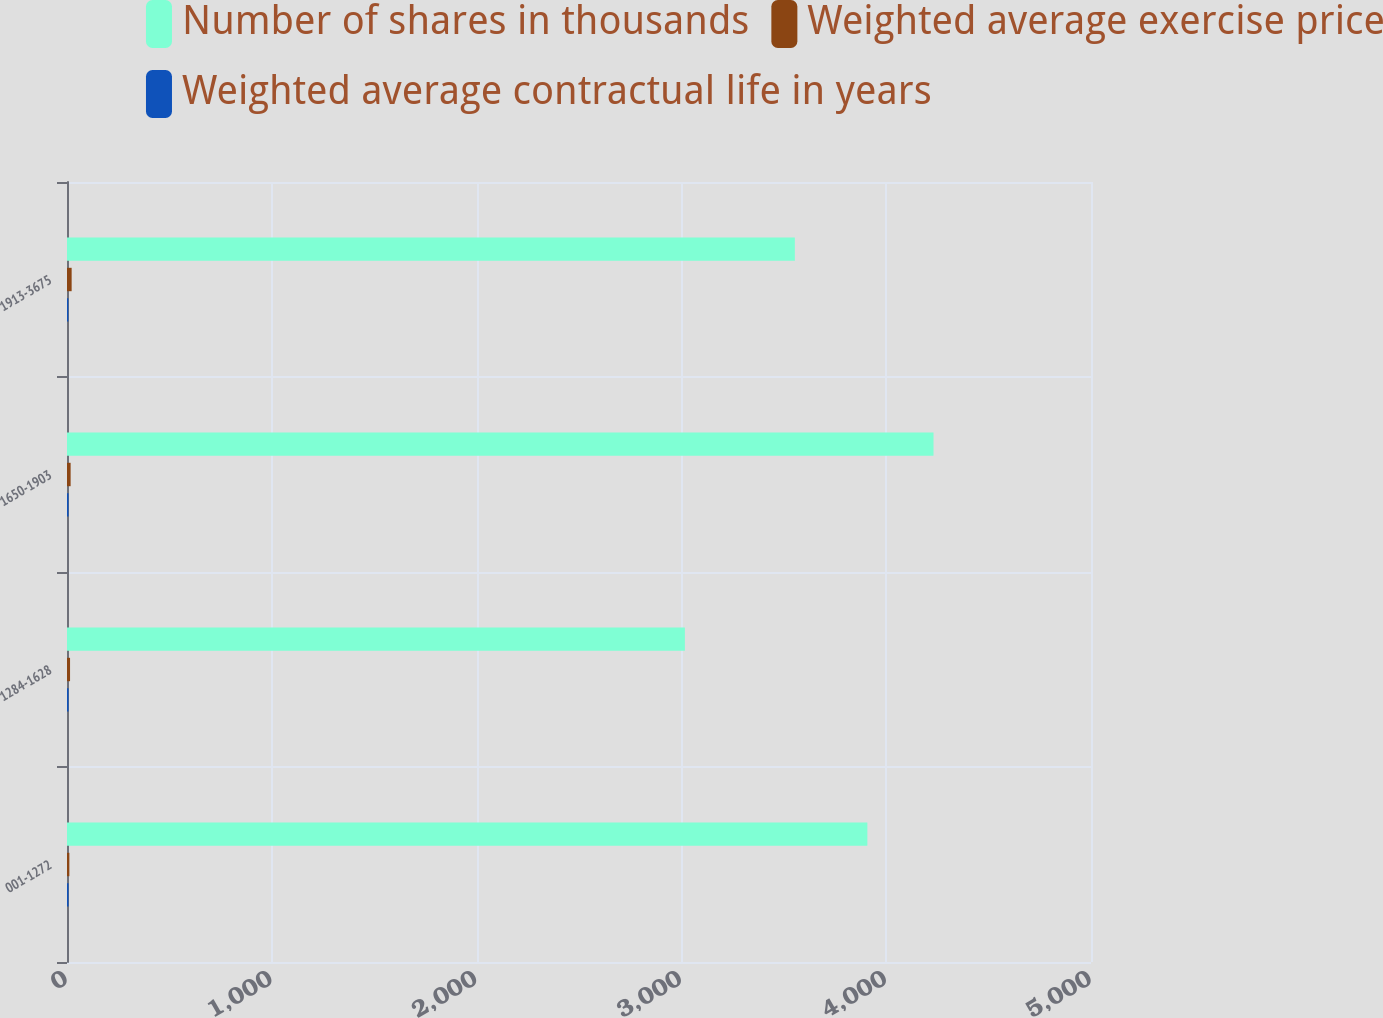<chart> <loc_0><loc_0><loc_500><loc_500><stacked_bar_chart><ecel><fcel>001-1272<fcel>1284-1628<fcel>1650-1903<fcel>1913-3675<nl><fcel>Number of shares in thousands<fcel>3908<fcel>3017<fcel>4231<fcel>3554<nl><fcel>Weighted average exercise price<fcel>11.49<fcel>14.89<fcel>17.69<fcel>22.68<nl><fcel>Weighted average contractual life in years<fcel>7.5<fcel>7.6<fcel>7.5<fcel>6.7<nl></chart> 